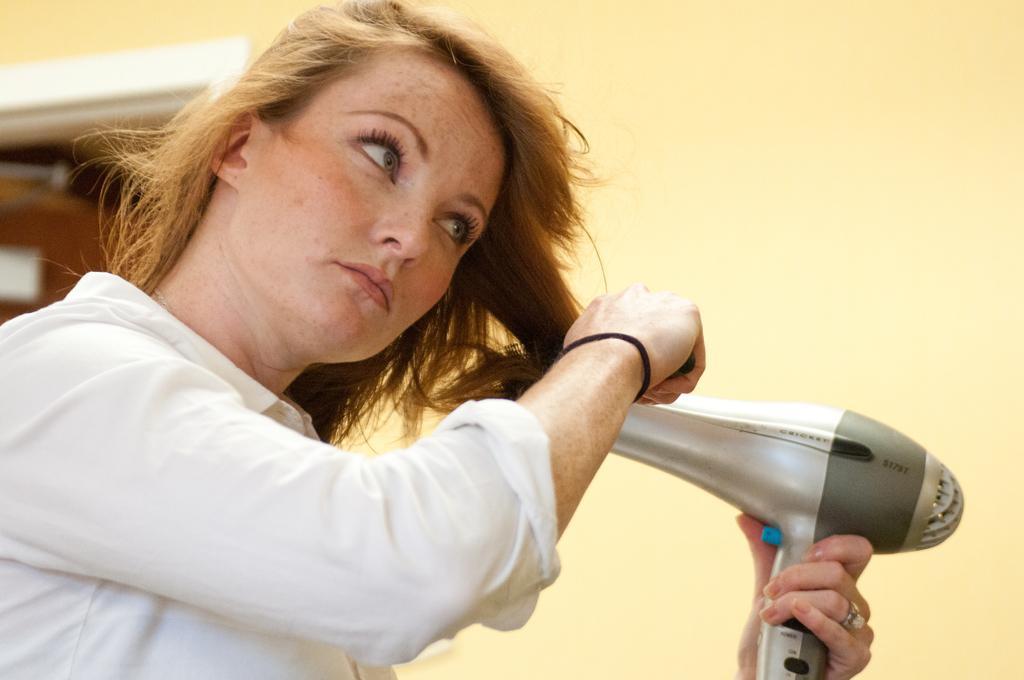Could you give a brief overview of what you see in this image? In this image in front there is a person holding the hair dryer. In the background of the image there is a wall. On the left side of the image there is a door. 